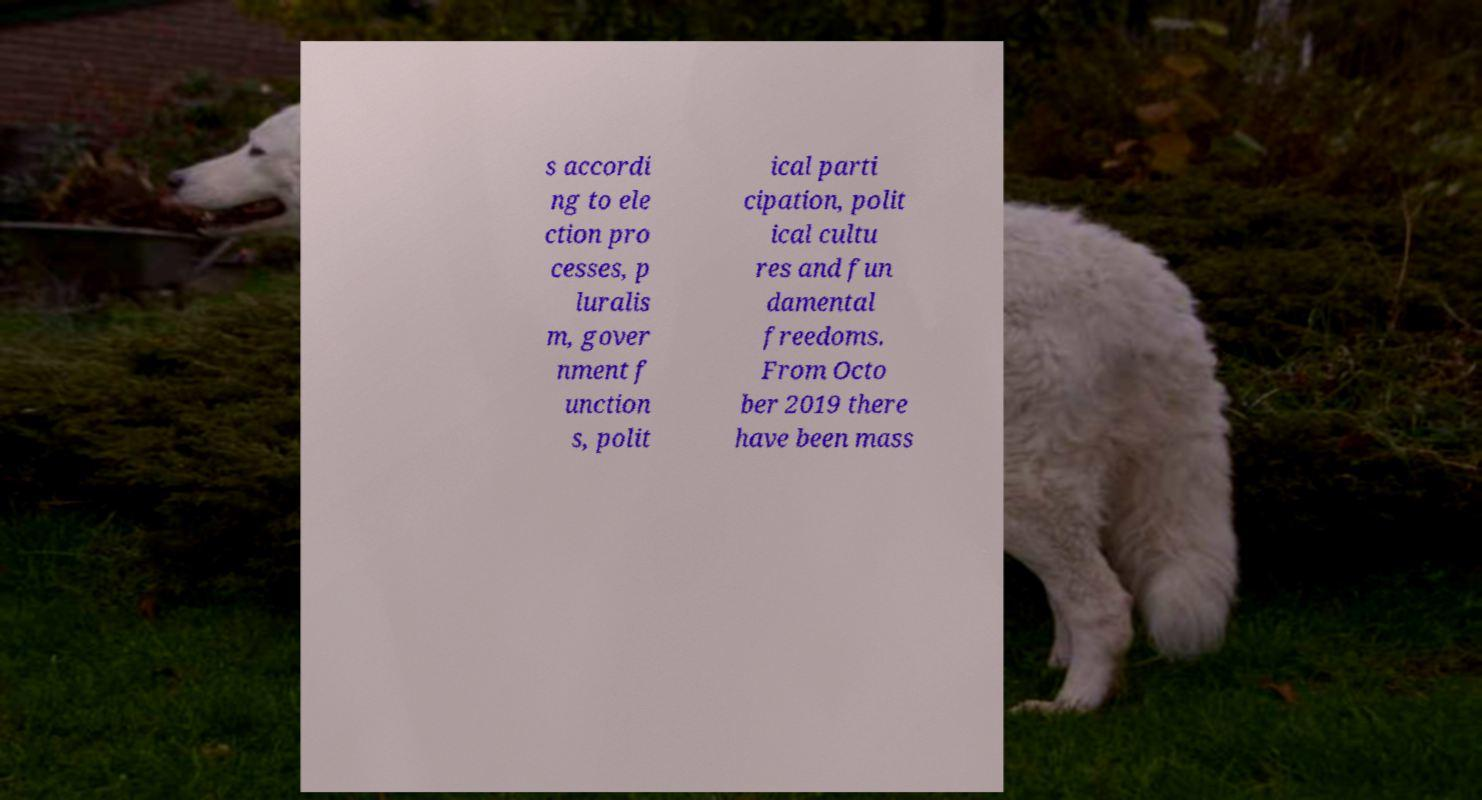Please identify and transcribe the text found in this image. s accordi ng to ele ction pro cesses, p luralis m, gover nment f unction s, polit ical parti cipation, polit ical cultu res and fun damental freedoms. From Octo ber 2019 there have been mass 